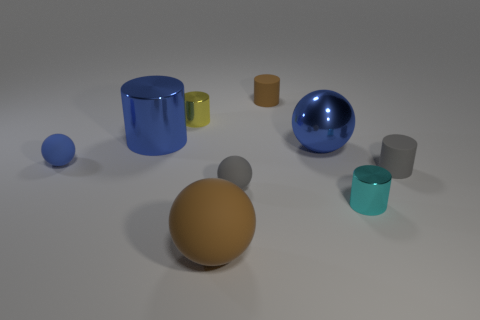Subtract all brown cubes. How many blue spheres are left? 2 Subtract all small blue rubber spheres. How many spheres are left? 3 Subtract all gray balls. How many balls are left? 3 Subtract 1 spheres. How many spheres are left? 3 Add 1 gray matte cylinders. How many objects exist? 10 Subtract all balls. How many objects are left? 5 Subtract all red cylinders. Subtract all yellow blocks. How many cylinders are left? 5 Subtract 1 blue cylinders. How many objects are left? 8 Subtract all tiny gray spheres. Subtract all large things. How many objects are left? 5 Add 8 tiny metallic objects. How many tiny metallic objects are left? 10 